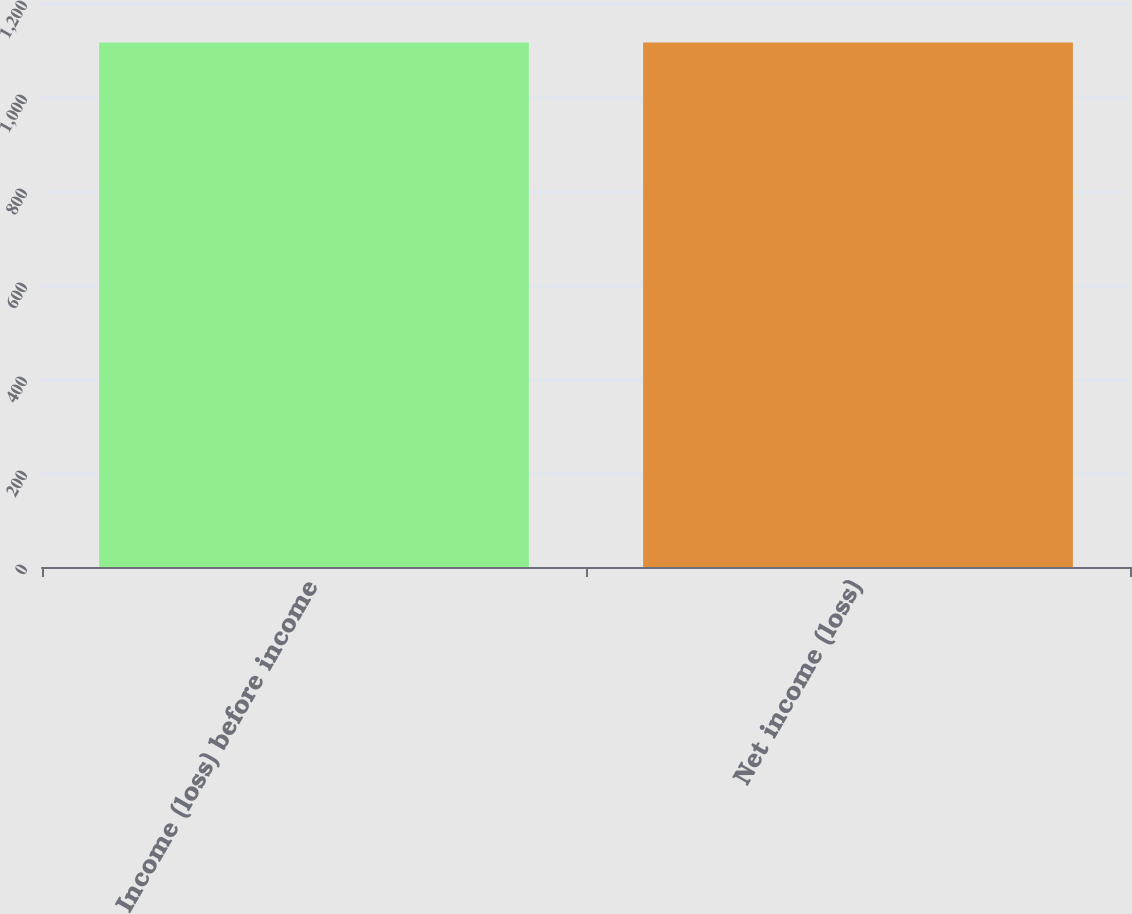<chart> <loc_0><loc_0><loc_500><loc_500><bar_chart><fcel>Income (loss) before income<fcel>Net income (loss)<nl><fcel>1116<fcel>1116.1<nl></chart> 